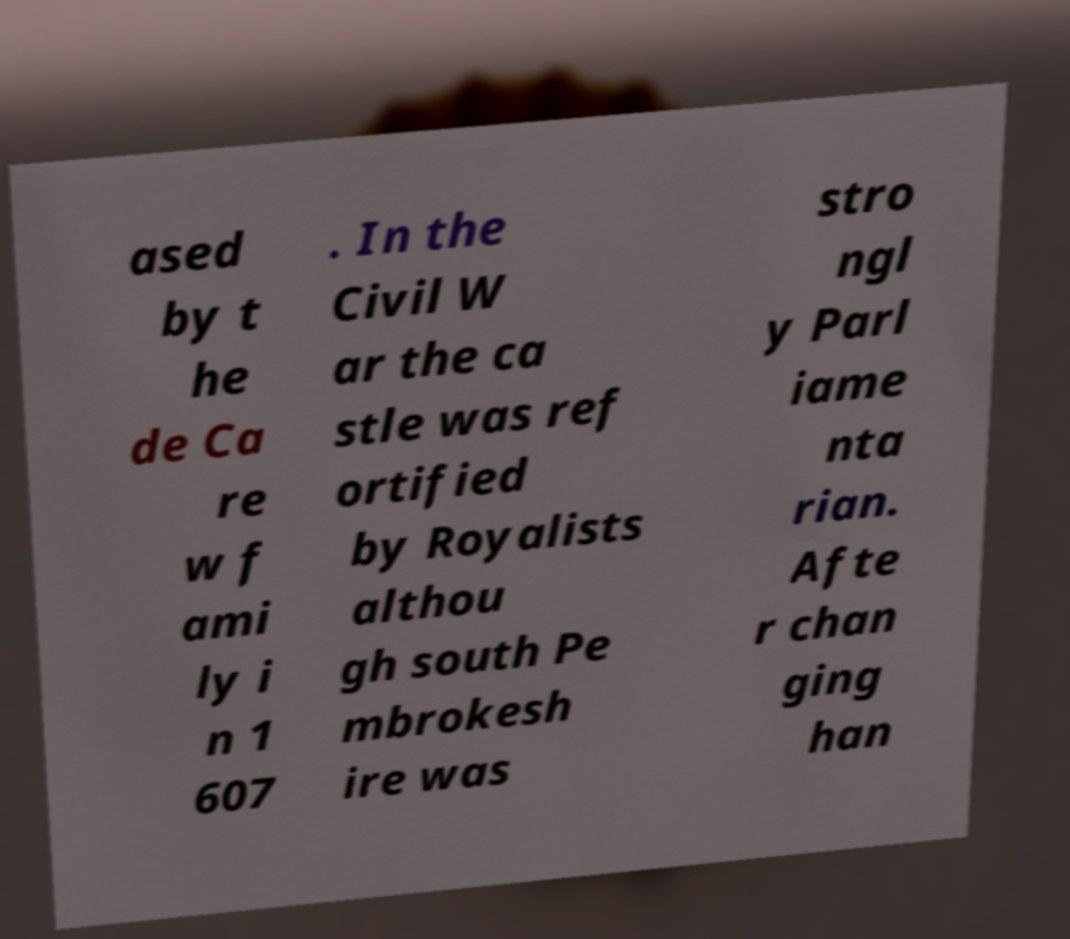Can you accurately transcribe the text from the provided image for me? ased by t he de Ca re w f ami ly i n 1 607 . In the Civil W ar the ca stle was ref ortified by Royalists althou gh south Pe mbrokesh ire was stro ngl y Parl iame nta rian. Afte r chan ging han 